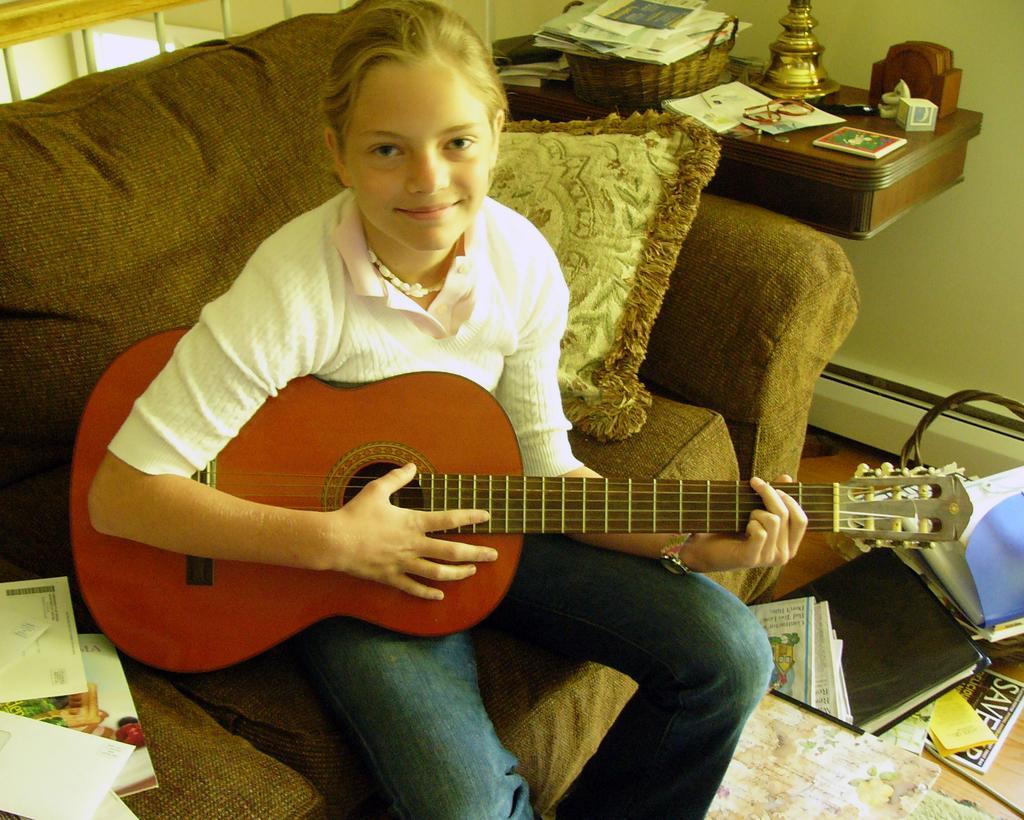In one or two sentences, can you explain what this image depicts? In this image there is a girl sitting on a sofa and holding a guitar. She is wearing white sweater and blue jeans. To the top right there is a desk, on the basket of papers, books, etc. In the bottom right there are some files, papers and books. 